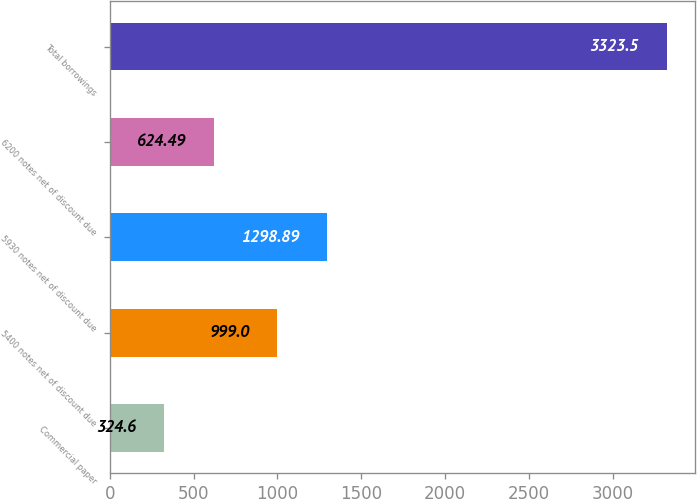<chart> <loc_0><loc_0><loc_500><loc_500><bar_chart><fcel>Commercial paper<fcel>5400 notes net of discount due<fcel>5930 notes net of discount due<fcel>6200 notes net of discount due<fcel>Total borrowings<nl><fcel>324.6<fcel>999<fcel>1298.89<fcel>624.49<fcel>3323.5<nl></chart> 